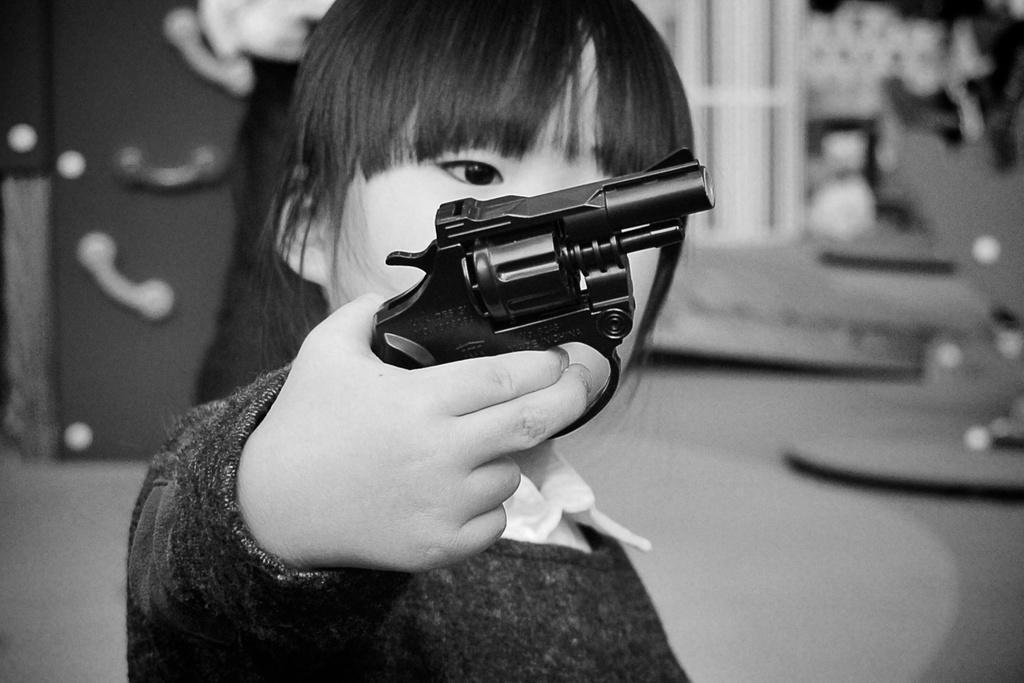Could you give a brief overview of what you see in this image? This is a black and white image, I can see a kid standing and holding a handgun. The background looks slightly blurred. 